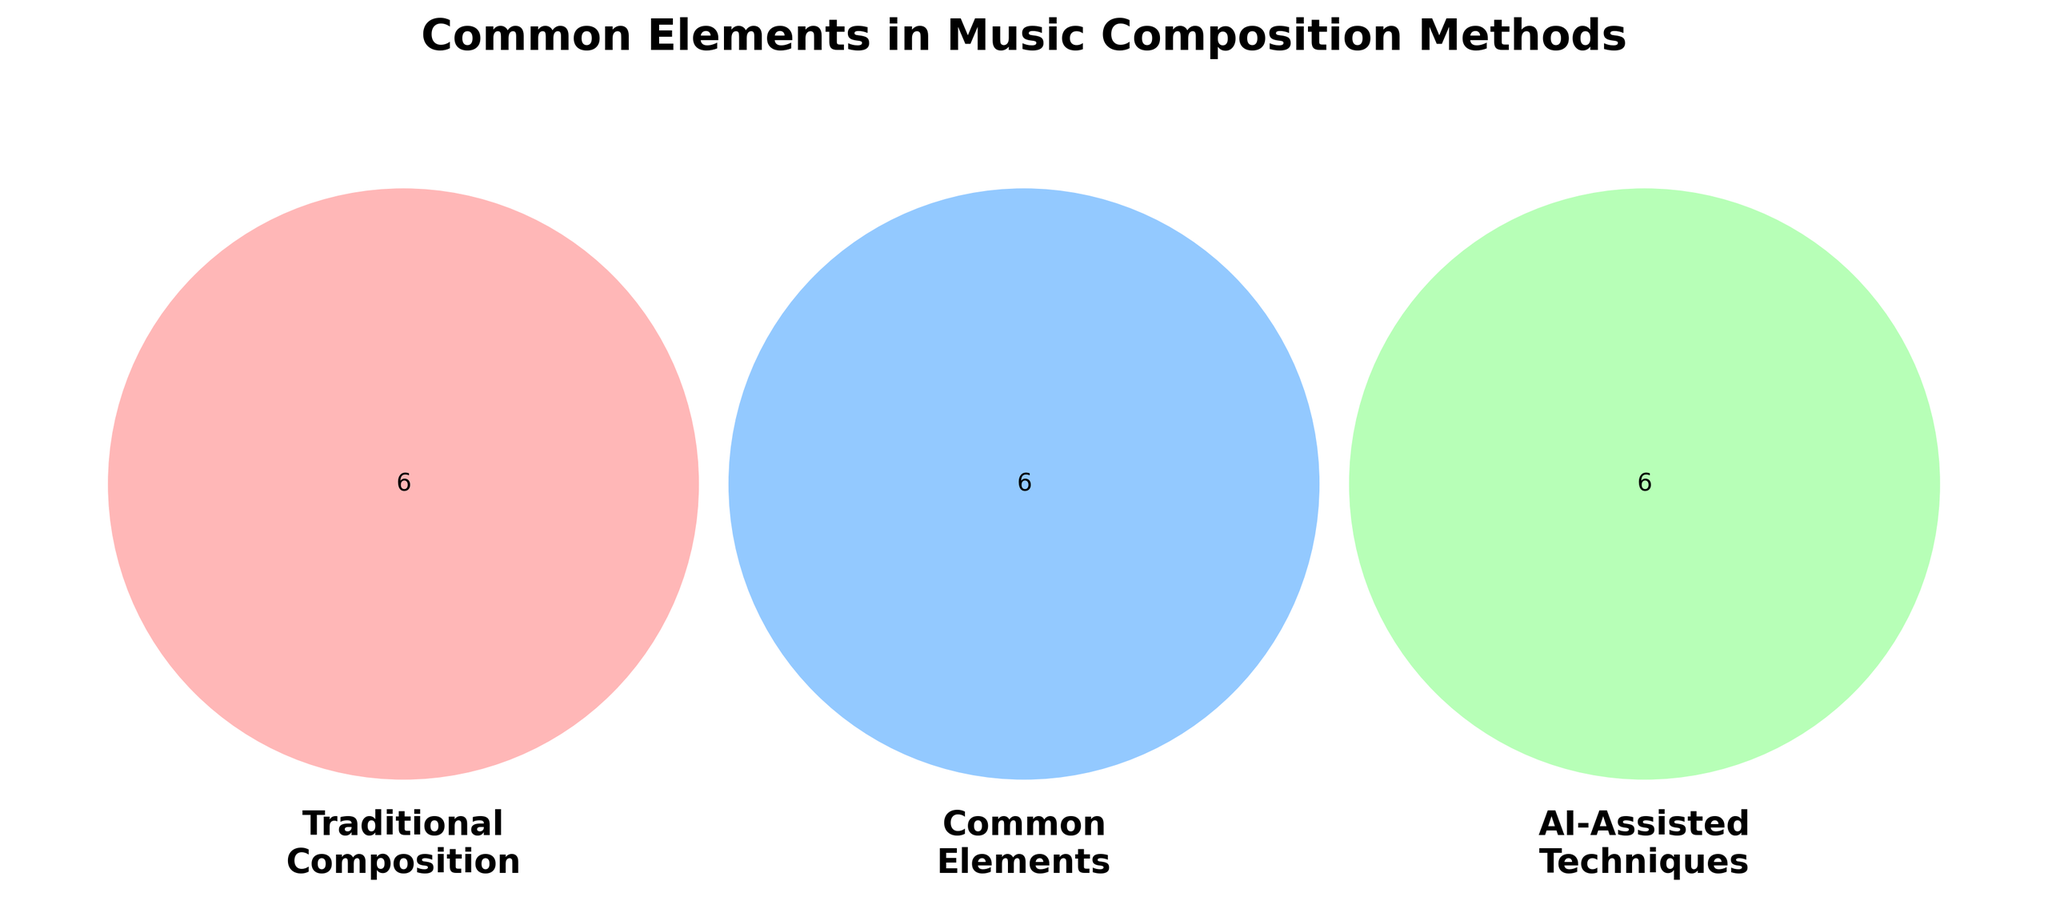What are the common elements between traditional composition and AI-assisted techniques? The overlapping area between 'Traditional Composition' and 'AI-Assisted Techniques' is labeled 'Common Elements'. It includes Musical theory knowledge, Melody creation, Rhythm patterns, Harmonic structure, Sound layering, and Improvisation.
Answer: Musical theory knowledge, Melody creation, Rhythm patterns, Harmonic structure, Sound layering, Improvisation What traditional composition method elements are not common with AI-assisted techniques? The elements exclusively in the 'Traditional Composition' circle are Notation software, Instrument proficiency, Music history awareness, Chord progressions, Hand-written scores, and Live performance.
Answer: Notation software, Instrument proficiency, Music history awareness, Chord progressions, Hand-written scores, Live performance Which elements are unique to AI-assisted techniques and not shared with traditional composition? The elements exclusively in the 'AI-Assisted Techniques' circle are Neural networks, Speech-to-MIDI conversion, Generative algorithms, Audio analysis tools, Machine learning models, and Real-time audio processing.
Answer: Neural networks, Speech-to-MIDI conversion, Generative algorithms, Audio analysis tools, Machine learning models, Real-time audio processing How many common elements are there between traditional composition and AI-assisted techniques? You need to count the elements in the overlapping 'Common Elements' section. There are six items listed there: Musical theory knowledge, Melody creation, Rhythm patterns, Harmonic structure, Sound layering, and Improvisation.
Answer: 6 Which side (traditional composition or AI-assisted techniques) has more unique elements? Count the elements in the exclusive sections of both circles. Traditional Composition has six unique elements, and AI-Assisted Techniques also have six unique elements. Both sides have an equal number of unique elements.
Answer: Equal Which elements does traditional composition share with AI-assisted techniques and not with common elements? Consider the elements listed in the overlapping section clearly labeled 'Common Elements'. None of the elements labeled in traditional composition or AI-assisted techniques are unique except the common elements shared between both sections.
Answer: None What is the sum of unique and common elements in traditional composition? Sum the elements in 'Traditional Composition' (6) and 'Common Elements' (6). The total is 6 unique elements + 6 shared elements.
Answer: 12 Are there elements shared between all three categories: traditional composition, common elements, and AI-assisted techniques? Check the center of the Venn Diagram. There are no elements in each set that overlap in the center where all three circles intersect.
Answer: No Which element belongs to AI-assisted techniques but not to any common elements? Elements in the 'AI-Assisted Techniques' circle without the 'Common Elements' include Neural networks, Speech-to-MIDI conversion, Generative algorithms, Audio analysis tools, Machine learning models, Real-time audio processing.
Answer: Neural networks, Speech-to-MIDI conversion, Generative algorithms, Audio analysis tools, Machine learning models, Real-time audio processing 